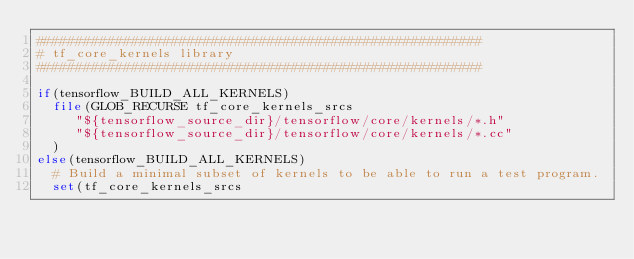Convert code to text. <code><loc_0><loc_0><loc_500><loc_500><_CMake_>########################################################
# tf_core_kernels library
########################################################

if(tensorflow_BUILD_ALL_KERNELS)
  file(GLOB_RECURSE tf_core_kernels_srcs
     "${tensorflow_source_dir}/tensorflow/core/kernels/*.h"
     "${tensorflow_source_dir}/tensorflow/core/kernels/*.cc"
  )
else(tensorflow_BUILD_ALL_KERNELS)
  # Build a minimal subset of kernels to be able to run a test program.
  set(tf_core_kernels_srcs</code> 